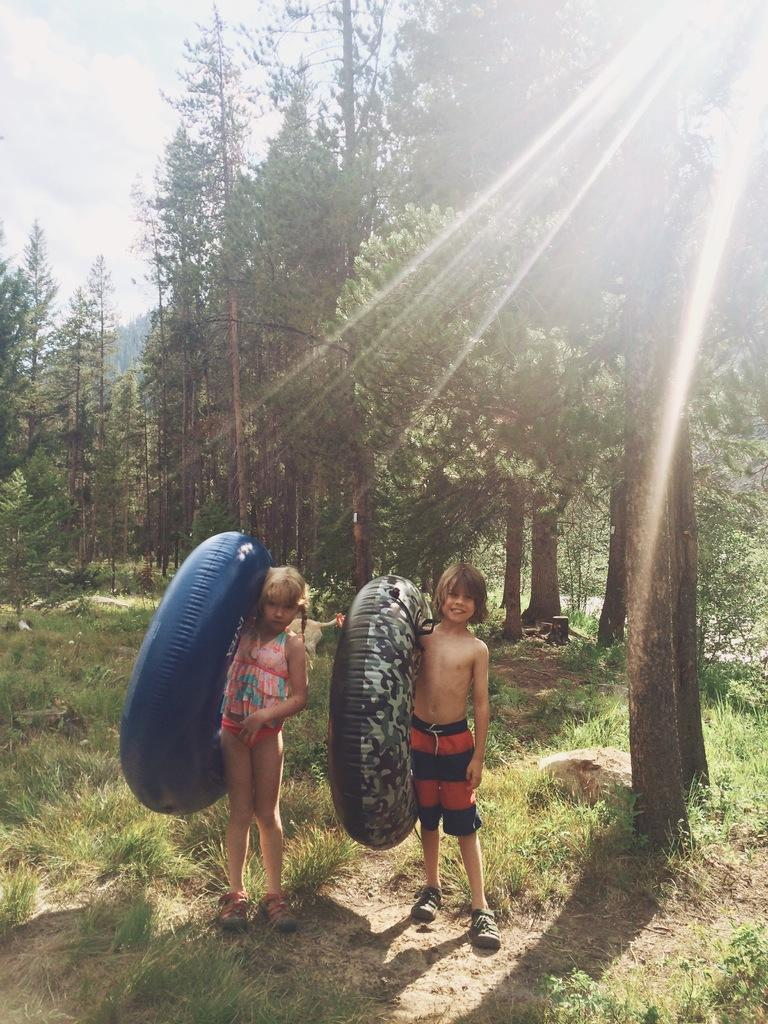Who are the main subjects in the foreground of the image? There is a girl and a boy in the foreground of the image. What are the girl and boy holding in the image? The girl and boy are holding swimming tubes. What can be seen in the background of the image? There are trees in the background of the image. What type of canvas is visible in the image? There is no canvas present in the image. How many cherries can be seen on the seat in the image? There is no seat or cherries present in the image. 